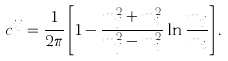<formula> <loc_0><loc_0><loc_500><loc_500>c ^ { i j } = \frac { 1 } { 2 \pi } \left [ 1 - \frac { m _ { j } ^ { 2 } + m _ { i } ^ { 2 } } { m _ { j } ^ { 2 } - m _ { i } ^ { 2 } } \ln \frac { m _ { j } } { m _ { i } } \right ] .</formula> 